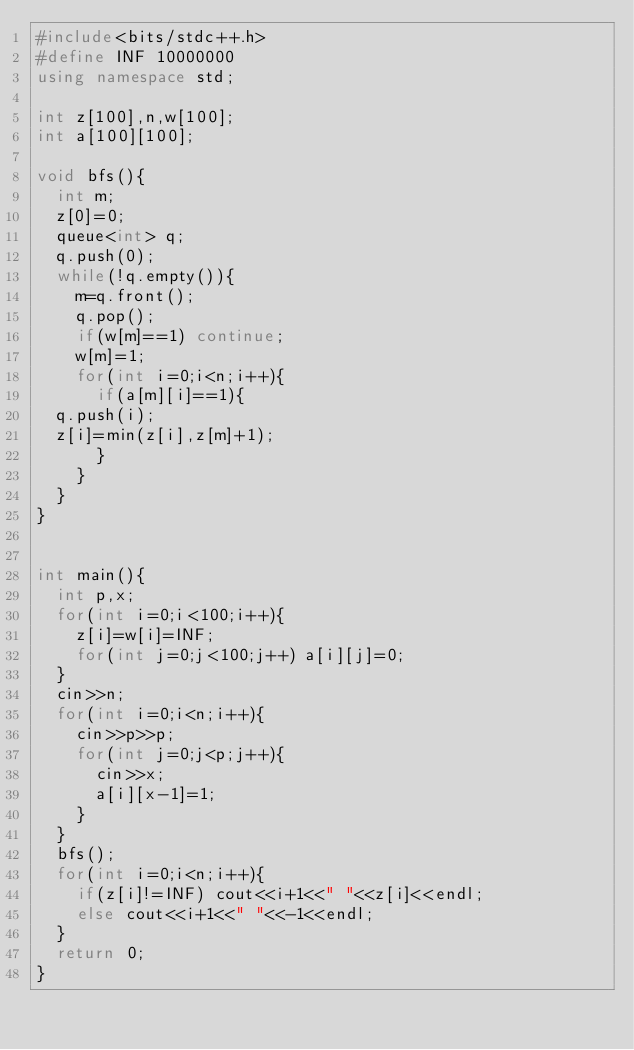Convert code to text. <code><loc_0><loc_0><loc_500><loc_500><_C++_>#include<bits/stdc++.h>
#define INF 10000000
using namespace std;

int z[100],n,w[100];
int a[100][100];

void bfs(){
  int m;
  z[0]=0;
  queue<int> q;
  q.push(0);
  while(!q.empty()){
    m=q.front();
    q.pop();
    if(w[m]==1) continue;
    w[m]=1;
    for(int i=0;i<n;i++){
      if(a[m][i]==1){
	q.push(i);
	z[i]=min(z[i],z[m]+1);
      }
    }
  }
}


int main(){
  int p,x;
  for(int i=0;i<100;i++){
    z[i]=w[i]=INF;
    for(int j=0;j<100;j++) a[i][j]=0;
  }
  cin>>n;
  for(int i=0;i<n;i++){
    cin>>p>>p;
    for(int j=0;j<p;j++){
      cin>>x;
      a[i][x-1]=1;
    }
  }
  bfs();
  for(int i=0;i<n;i++){
    if(z[i]!=INF) cout<<i+1<<" "<<z[i]<<endl;
    else cout<<i+1<<" "<<-1<<endl;
  }
  return 0;
}

</code> 